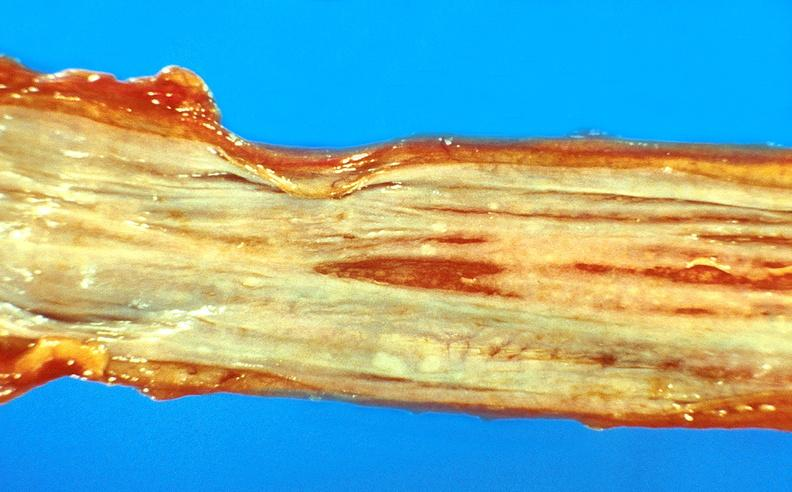s siamese twins present?
Answer the question using a single word or phrase. No 